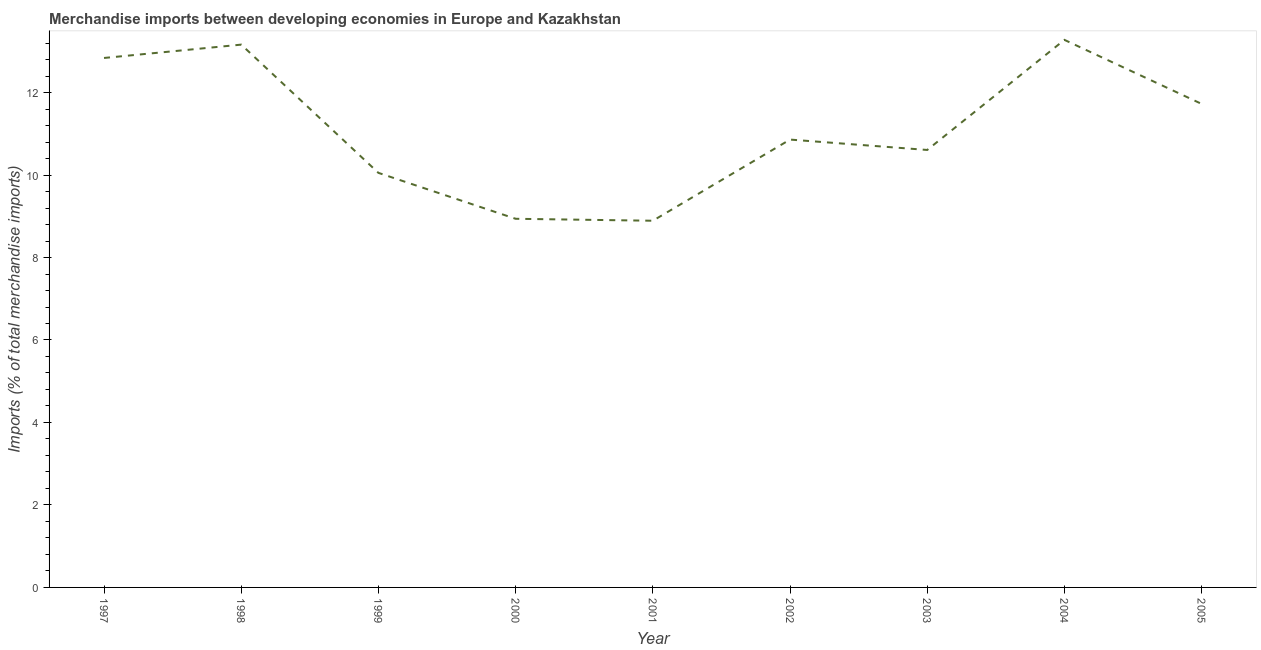What is the merchandise imports in 2001?
Your answer should be compact. 8.89. Across all years, what is the maximum merchandise imports?
Make the answer very short. 13.28. Across all years, what is the minimum merchandise imports?
Give a very brief answer. 8.89. What is the sum of the merchandise imports?
Your response must be concise. 100.36. What is the difference between the merchandise imports in 1997 and 2004?
Your answer should be compact. -0.44. What is the average merchandise imports per year?
Keep it short and to the point. 11.15. What is the median merchandise imports?
Offer a terse response. 10.86. In how many years, is the merchandise imports greater than 9.2 %?
Keep it short and to the point. 7. Do a majority of the years between 1999 and 2005 (inclusive) have merchandise imports greater than 2.4 %?
Your answer should be compact. Yes. What is the ratio of the merchandise imports in 1997 to that in 2005?
Your answer should be compact. 1.09. What is the difference between the highest and the second highest merchandise imports?
Make the answer very short. 0.12. Is the sum of the merchandise imports in 2003 and 2005 greater than the maximum merchandise imports across all years?
Keep it short and to the point. Yes. What is the difference between the highest and the lowest merchandise imports?
Keep it short and to the point. 4.39. Does the merchandise imports monotonically increase over the years?
Keep it short and to the point. No. How many lines are there?
Offer a terse response. 1. Does the graph contain grids?
Keep it short and to the point. No. What is the title of the graph?
Offer a terse response. Merchandise imports between developing economies in Europe and Kazakhstan. What is the label or title of the Y-axis?
Provide a succinct answer. Imports (% of total merchandise imports). What is the Imports (% of total merchandise imports) of 1997?
Keep it short and to the point. 12.84. What is the Imports (% of total merchandise imports) in 1998?
Offer a terse response. 13.16. What is the Imports (% of total merchandise imports) in 1999?
Keep it short and to the point. 10.05. What is the Imports (% of total merchandise imports) of 2000?
Provide a short and direct response. 8.94. What is the Imports (% of total merchandise imports) of 2001?
Provide a short and direct response. 8.89. What is the Imports (% of total merchandise imports) in 2002?
Ensure brevity in your answer.  10.86. What is the Imports (% of total merchandise imports) of 2003?
Offer a terse response. 10.61. What is the Imports (% of total merchandise imports) in 2004?
Your answer should be compact. 13.28. What is the Imports (% of total merchandise imports) of 2005?
Make the answer very short. 11.73. What is the difference between the Imports (% of total merchandise imports) in 1997 and 1998?
Your response must be concise. -0.32. What is the difference between the Imports (% of total merchandise imports) in 1997 and 1999?
Provide a short and direct response. 2.79. What is the difference between the Imports (% of total merchandise imports) in 1997 and 2000?
Ensure brevity in your answer.  3.9. What is the difference between the Imports (% of total merchandise imports) in 1997 and 2001?
Provide a short and direct response. 3.95. What is the difference between the Imports (% of total merchandise imports) in 1997 and 2002?
Ensure brevity in your answer.  1.98. What is the difference between the Imports (% of total merchandise imports) in 1997 and 2003?
Your answer should be very brief. 2.23. What is the difference between the Imports (% of total merchandise imports) in 1997 and 2004?
Keep it short and to the point. -0.44. What is the difference between the Imports (% of total merchandise imports) in 1997 and 2005?
Keep it short and to the point. 1.11. What is the difference between the Imports (% of total merchandise imports) in 1998 and 1999?
Provide a succinct answer. 3.11. What is the difference between the Imports (% of total merchandise imports) in 1998 and 2000?
Provide a succinct answer. 4.22. What is the difference between the Imports (% of total merchandise imports) in 1998 and 2001?
Ensure brevity in your answer.  4.27. What is the difference between the Imports (% of total merchandise imports) in 1998 and 2002?
Provide a succinct answer. 2.3. What is the difference between the Imports (% of total merchandise imports) in 1998 and 2003?
Offer a terse response. 2.55. What is the difference between the Imports (% of total merchandise imports) in 1998 and 2004?
Give a very brief answer. -0.12. What is the difference between the Imports (% of total merchandise imports) in 1998 and 2005?
Keep it short and to the point. 1.44. What is the difference between the Imports (% of total merchandise imports) in 1999 and 2000?
Provide a short and direct response. 1.11. What is the difference between the Imports (% of total merchandise imports) in 1999 and 2001?
Offer a terse response. 1.16. What is the difference between the Imports (% of total merchandise imports) in 1999 and 2002?
Provide a succinct answer. -0.81. What is the difference between the Imports (% of total merchandise imports) in 1999 and 2003?
Your response must be concise. -0.56. What is the difference between the Imports (% of total merchandise imports) in 1999 and 2004?
Ensure brevity in your answer.  -3.23. What is the difference between the Imports (% of total merchandise imports) in 1999 and 2005?
Your response must be concise. -1.67. What is the difference between the Imports (% of total merchandise imports) in 2000 and 2001?
Give a very brief answer. 0.05. What is the difference between the Imports (% of total merchandise imports) in 2000 and 2002?
Ensure brevity in your answer.  -1.92. What is the difference between the Imports (% of total merchandise imports) in 2000 and 2003?
Your response must be concise. -1.67. What is the difference between the Imports (% of total merchandise imports) in 2000 and 2004?
Offer a terse response. -4.34. What is the difference between the Imports (% of total merchandise imports) in 2000 and 2005?
Provide a short and direct response. -2.79. What is the difference between the Imports (% of total merchandise imports) in 2001 and 2002?
Provide a succinct answer. -1.97. What is the difference between the Imports (% of total merchandise imports) in 2001 and 2003?
Ensure brevity in your answer.  -1.72. What is the difference between the Imports (% of total merchandise imports) in 2001 and 2004?
Offer a very short reply. -4.39. What is the difference between the Imports (% of total merchandise imports) in 2001 and 2005?
Ensure brevity in your answer.  -2.83. What is the difference between the Imports (% of total merchandise imports) in 2002 and 2003?
Your answer should be compact. 0.25. What is the difference between the Imports (% of total merchandise imports) in 2002 and 2004?
Provide a succinct answer. -2.42. What is the difference between the Imports (% of total merchandise imports) in 2002 and 2005?
Ensure brevity in your answer.  -0.87. What is the difference between the Imports (% of total merchandise imports) in 2003 and 2004?
Keep it short and to the point. -2.67. What is the difference between the Imports (% of total merchandise imports) in 2003 and 2005?
Keep it short and to the point. -1.12. What is the difference between the Imports (% of total merchandise imports) in 2004 and 2005?
Keep it short and to the point. 1.55. What is the ratio of the Imports (% of total merchandise imports) in 1997 to that in 1999?
Keep it short and to the point. 1.28. What is the ratio of the Imports (% of total merchandise imports) in 1997 to that in 2000?
Your answer should be compact. 1.44. What is the ratio of the Imports (% of total merchandise imports) in 1997 to that in 2001?
Provide a short and direct response. 1.44. What is the ratio of the Imports (% of total merchandise imports) in 1997 to that in 2002?
Your response must be concise. 1.18. What is the ratio of the Imports (% of total merchandise imports) in 1997 to that in 2003?
Ensure brevity in your answer.  1.21. What is the ratio of the Imports (% of total merchandise imports) in 1997 to that in 2004?
Keep it short and to the point. 0.97. What is the ratio of the Imports (% of total merchandise imports) in 1997 to that in 2005?
Your answer should be compact. 1.09. What is the ratio of the Imports (% of total merchandise imports) in 1998 to that in 1999?
Your answer should be compact. 1.31. What is the ratio of the Imports (% of total merchandise imports) in 1998 to that in 2000?
Offer a very short reply. 1.47. What is the ratio of the Imports (% of total merchandise imports) in 1998 to that in 2001?
Provide a short and direct response. 1.48. What is the ratio of the Imports (% of total merchandise imports) in 1998 to that in 2002?
Your response must be concise. 1.21. What is the ratio of the Imports (% of total merchandise imports) in 1998 to that in 2003?
Keep it short and to the point. 1.24. What is the ratio of the Imports (% of total merchandise imports) in 1998 to that in 2004?
Offer a terse response. 0.99. What is the ratio of the Imports (% of total merchandise imports) in 1998 to that in 2005?
Ensure brevity in your answer.  1.12. What is the ratio of the Imports (% of total merchandise imports) in 1999 to that in 2001?
Ensure brevity in your answer.  1.13. What is the ratio of the Imports (% of total merchandise imports) in 1999 to that in 2002?
Offer a very short reply. 0.93. What is the ratio of the Imports (% of total merchandise imports) in 1999 to that in 2003?
Give a very brief answer. 0.95. What is the ratio of the Imports (% of total merchandise imports) in 1999 to that in 2004?
Offer a terse response. 0.76. What is the ratio of the Imports (% of total merchandise imports) in 1999 to that in 2005?
Your answer should be very brief. 0.86. What is the ratio of the Imports (% of total merchandise imports) in 2000 to that in 2002?
Your response must be concise. 0.82. What is the ratio of the Imports (% of total merchandise imports) in 2000 to that in 2003?
Give a very brief answer. 0.84. What is the ratio of the Imports (% of total merchandise imports) in 2000 to that in 2004?
Make the answer very short. 0.67. What is the ratio of the Imports (% of total merchandise imports) in 2000 to that in 2005?
Your answer should be compact. 0.76. What is the ratio of the Imports (% of total merchandise imports) in 2001 to that in 2002?
Ensure brevity in your answer.  0.82. What is the ratio of the Imports (% of total merchandise imports) in 2001 to that in 2003?
Ensure brevity in your answer.  0.84. What is the ratio of the Imports (% of total merchandise imports) in 2001 to that in 2004?
Offer a terse response. 0.67. What is the ratio of the Imports (% of total merchandise imports) in 2001 to that in 2005?
Ensure brevity in your answer.  0.76. What is the ratio of the Imports (% of total merchandise imports) in 2002 to that in 2004?
Offer a terse response. 0.82. What is the ratio of the Imports (% of total merchandise imports) in 2002 to that in 2005?
Provide a succinct answer. 0.93. What is the ratio of the Imports (% of total merchandise imports) in 2003 to that in 2004?
Make the answer very short. 0.8. What is the ratio of the Imports (% of total merchandise imports) in 2003 to that in 2005?
Provide a succinct answer. 0.91. What is the ratio of the Imports (% of total merchandise imports) in 2004 to that in 2005?
Your response must be concise. 1.13. 